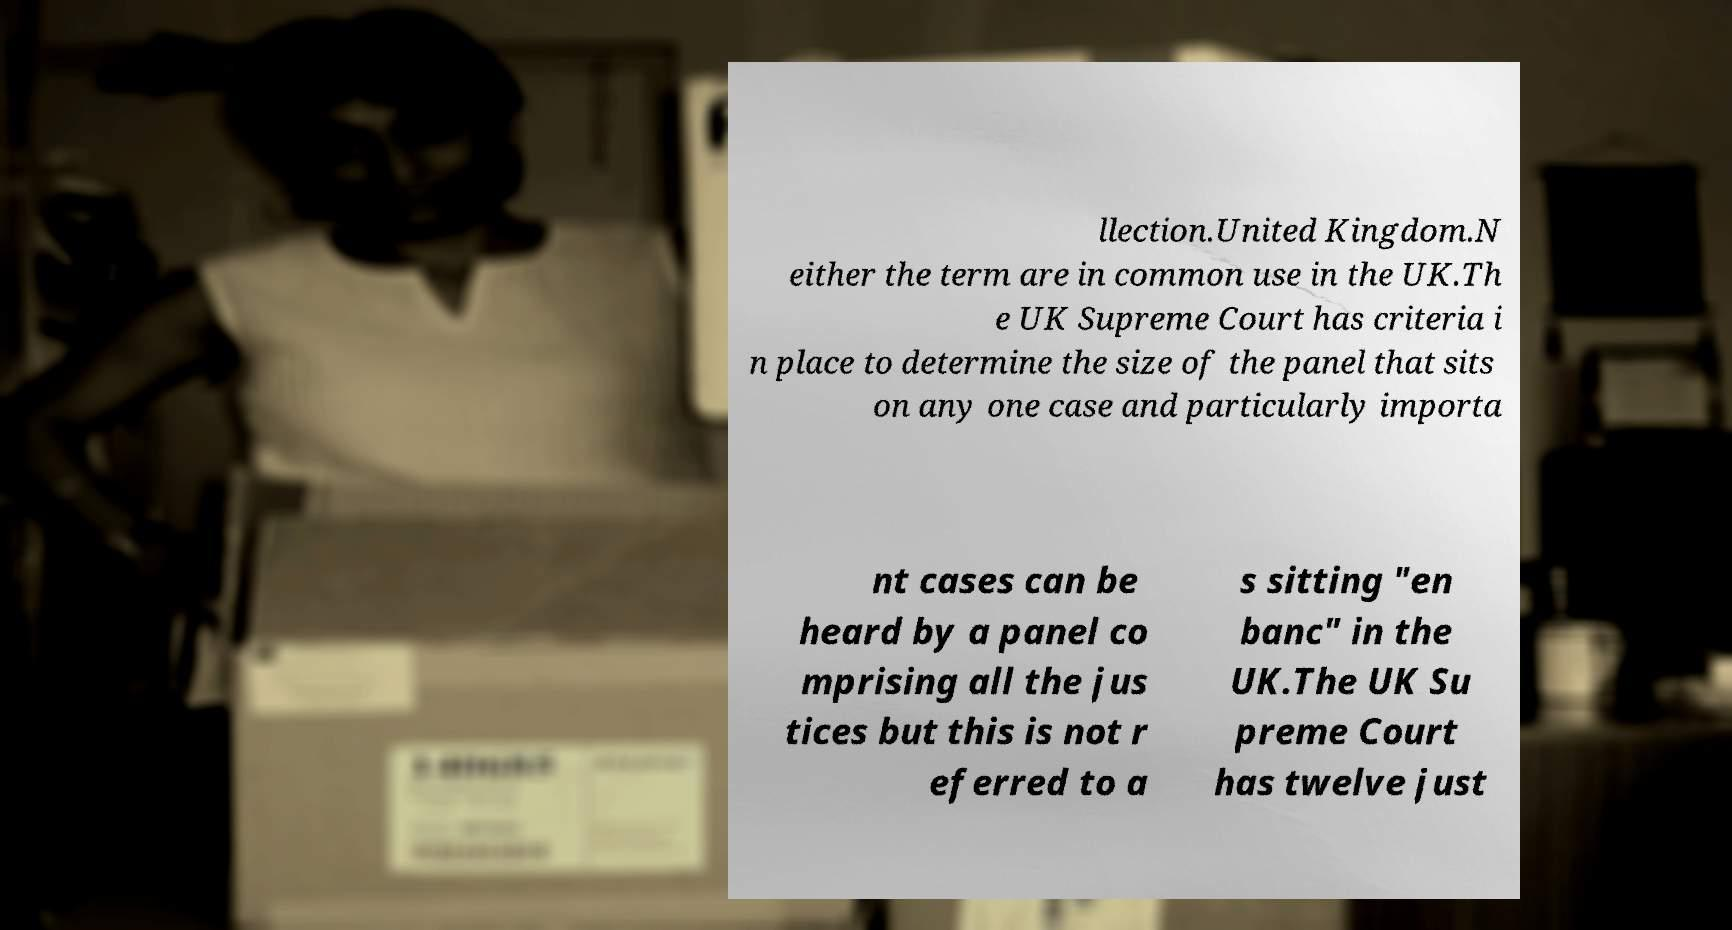There's text embedded in this image that I need extracted. Can you transcribe it verbatim? llection.United Kingdom.N either the term are in common use in the UK.Th e UK Supreme Court has criteria i n place to determine the size of the panel that sits on any one case and particularly importa nt cases can be heard by a panel co mprising all the jus tices but this is not r eferred to a s sitting "en banc" in the UK.The UK Su preme Court has twelve just 